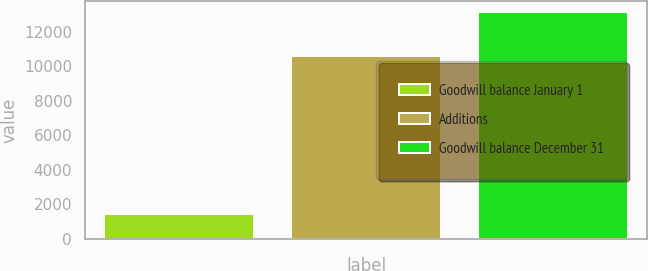Convert chart to OTSL. <chart><loc_0><loc_0><loc_500><loc_500><bar_chart><fcel>Goodwill balance January 1<fcel>Additions<fcel>Goodwill balance December 31<nl><fcel>1439<fcel>10599<fcel>13131.9<nl></chart> 